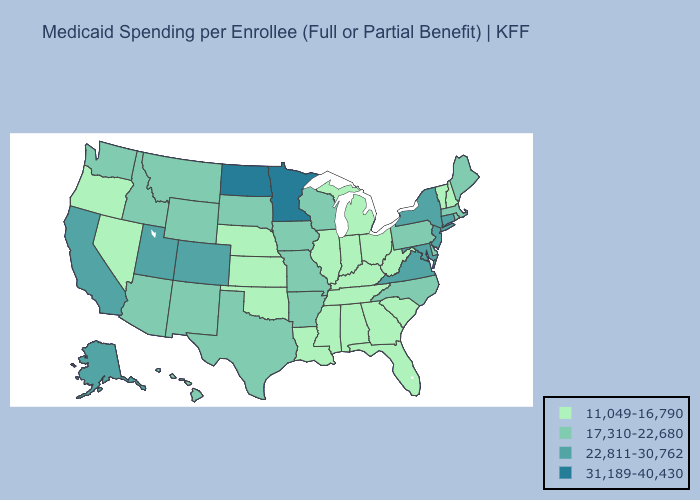How many symbols are there in the legend?
Be succinct. 4. Does Minnesota have the highest value in the USA?
Concise answer only. Yes. Name the states that have a value in the range 22,811-30,762?
Answer briefly. Alaska, California, Colorado, Connecticut, Maryland, New Jersey, New York, Utah, Virginia. Name the states that have a value in the range 31,189-40,430?
Quick response, please. Minnesota, North Dakota. Which states have the lowest value in the MidWest?
Be succinct. Illinois, Indiana, Kansas, Michigan, Nebraska, Ohio. Name the states that have a value in the range 11,049-16,790?
Give a very brief answer. Alabama, Florida, Georgia, Illinois, Indiana, Kansas, Kentucky, Louisiana, Michigan, Mississippi, Nebraska, Nevada, New Hampshire, Ohio, Oklahoma, Oregon, South Carolina, Tennessee, Vermont, West Virginia. What is the value of California?
Write a very short answer. 22,811-30,762. What is the value of Nevada?
Give a very brief answer. 11,049-16,790. Name the states that have a value in the range 17,310-22,680?
Answer briefly. Arizona, Arkansas, Delaware, Hawaii, Idaho, Iowa, Maine, Massachusetts, Missouri, Montana, New Mexico, North Carolina, Pennsylvania, Rhode Island, South Dakota, Texas, Washington, Wisconsin, Wyoming. Among the states that border Tennessee , does North Carolina have the lowest value?
Quick response, please. No. Name the states that have a value in the range 17,310-22,680?
Give a very brief answer. Arizona, Arkansas, Delaware, Hawaii, Idaho, Iowa, Maine, Massachusetts, Missouri, Montana, New Mexico, North Carolina, Pennsylvania, Rhode Island, South Dakota, Texas, Washington, Wisconsin, Wyoming. Name the states that have a value in the range 17,310-22,680?
Keep it brief. Arizona, Arkansas, Delaware, Hawaii, Idaho, Iowa, Maine, Massachusetts, Missouri, Montana, New Mexico, North Carolina, Pennsylvania, Rhode Island, South Dakota, Texas, Washington, Wisconsin, Wyoming. Which states have the lowest value in the USA?
Quick response, please. Alabama, Florida, Georgia, Illinois, Indiana, Kansas, Kentucky, Louisiana, Michigan, Mississippi, Nebraska, Nevada, New Hampshire, Ohio, Oklahoma, Oregon, South Carolina, Tennessee, Vermont, West Virginia. What is the value of Nevada?
Short answer required. 11,049-16,790. 